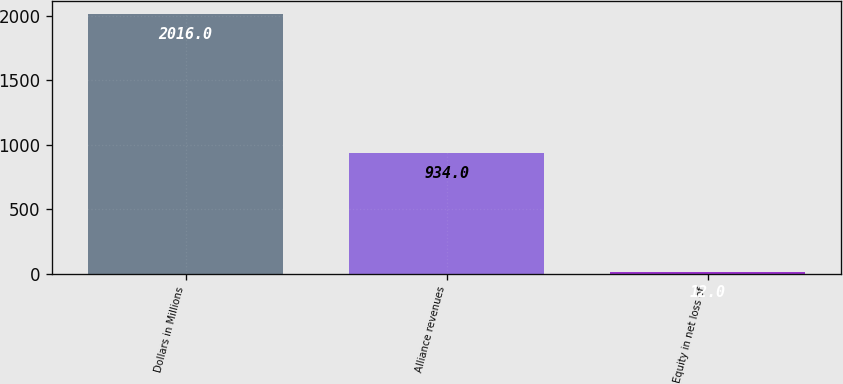Convert chart. <chart><loc_0><loc_0><loc_500><loc_500><bar_chart><fcel>Dollars in Millions<fcel>Alliance revenues<fcel>Equity in net loss of<nl><fcel>2016<fcel>934<fcel>12<nl></chart> 